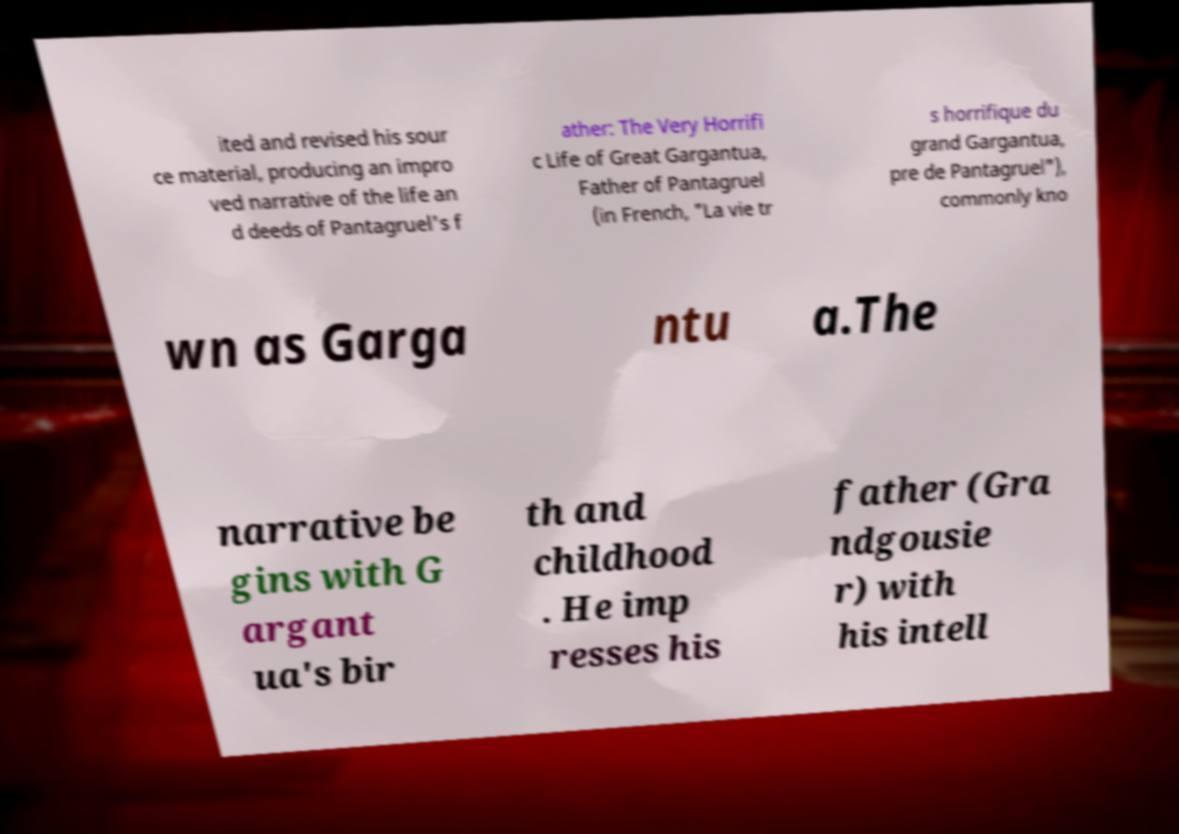For documentation purposes, I need the text within this image transcribed. Could you provide that? ited and revised his sour ce material, producing an impro ved narrative of the life an d deeds of Pantagruel's f ather: The Very Horrifi c Life of Great Gargantua, Father of Pantagruel (in French, "La vie tr s horrifique du grand Gargantua, pre de Pantagruel"), commonly kno wn as Garga ntu a.The narrative be gins with G argant ua's bir th and childhood . He imp resses his father (Gra ndgousie r) with his intell 